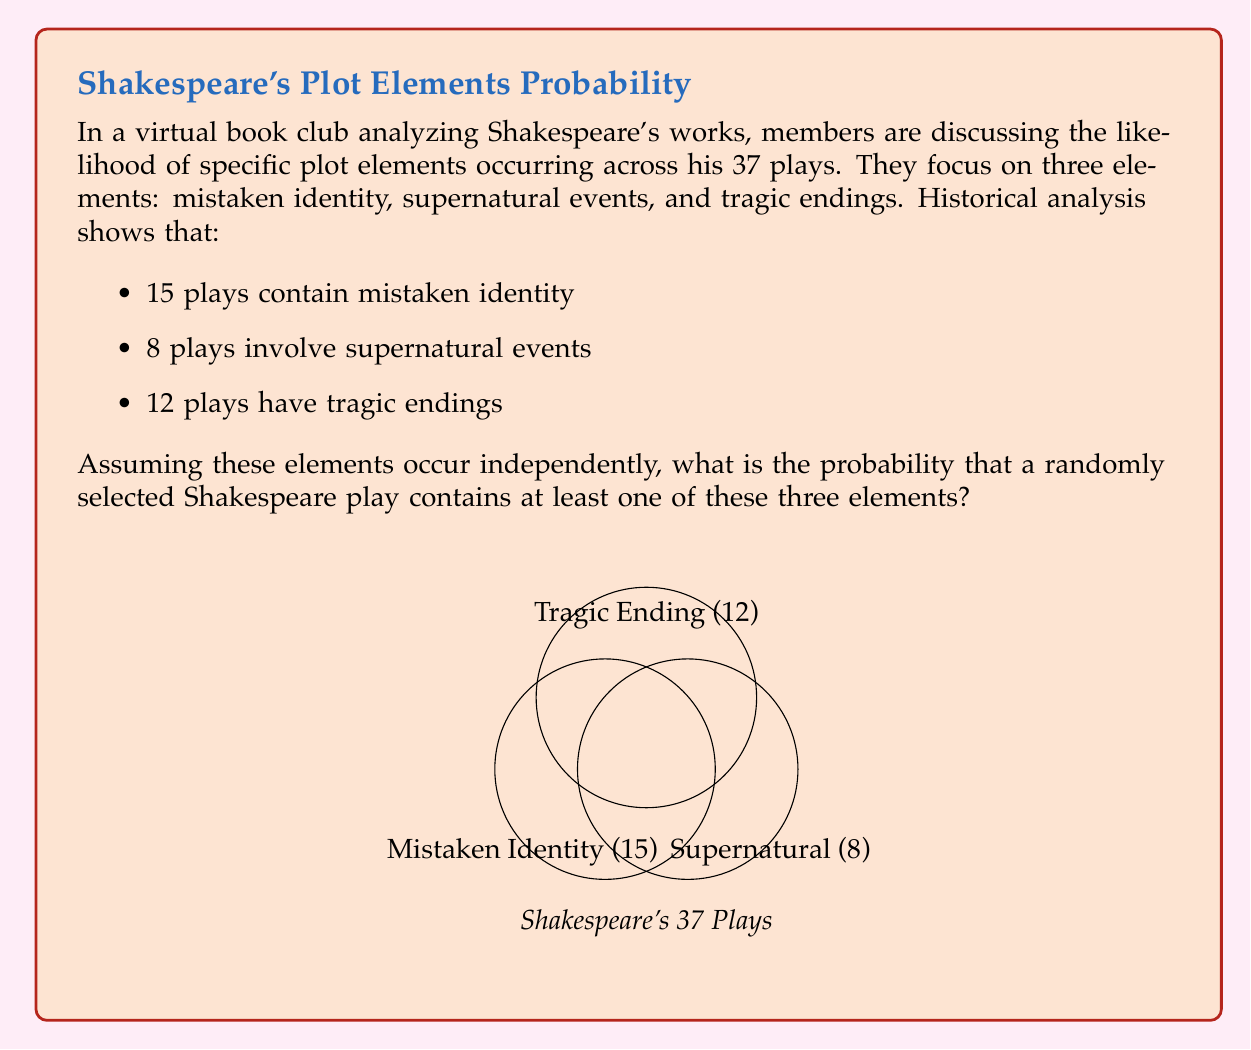What is the answer to this math problem? To solve this problem, we'll use the concept of probability and the principle of inclusion-exclusion.

Step 1: Calculate the probability of each element occurring:
P(Mistaken Identity) = 15/37
P(Supernatural) = 8/37
P(Tragic Ending) = 12/37

Step 2: Calculate the probability of none of these elements occurring:
P(None) = (1 - 15/37) * (1 - 8/37) * (1 - 12/37)
        = (22/37) * (29/37) * (25/37)
        = 15950 / 50653
        ≈ 0.3149

Step 3: The probability of at least one element occurring is the complement of the probability of none occurring:
P(At least one) = 1 - P(None)
                = 1 - 15950/50653
                = 34703/50653
                ≈ 0.6851

Therefore, the probability that a randomly selected Shakespeare play contains at least one of these three elements is 34703/50653 or approximately 68.51%.
Answer: $\frac{34703}{50653}$ or approximately $0.6851$ (68.51%) 